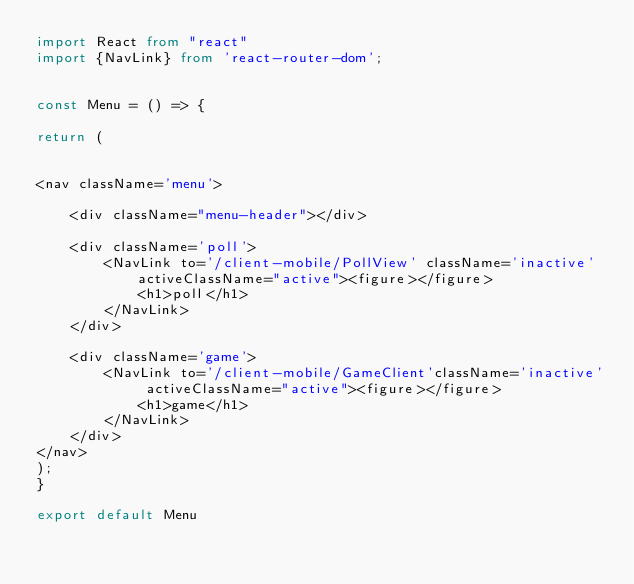Convert code to text. <code><loc_0><loc_0><loc_500><loc_500><_TypeScript_>import React from "react"
import {NavLink} from 'react-router-dom';


const Menu = () => {

return (


<nav className='menu'>

    <div className="menu-header"></div>

    <div className='poll'>
    	<NavLink to='/client-mobile/PollView' className='inactive' activeClassName="active"><figure></figure>
    		<h1>poll</h1>
    	</NavLink>
    </div>
    
    <div className='game'>
    	<NavLink to='/client-mobile/GameClient'className='inactive' activeClassName="active"><figure></figure>
    		<h1>game</h1>
    	</NavLink>
    </div>
</nav>
);
}   	

export default Menu
</code> 